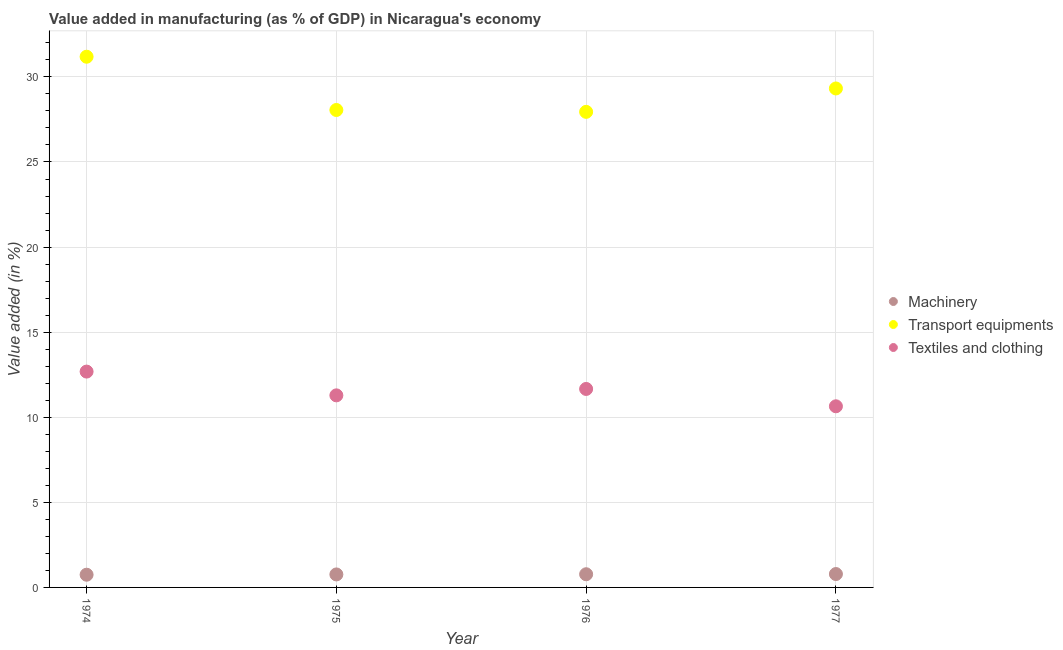Is the number of dotlines equal to the number of legend labels?
Provide a short and direct response. Yes. What is the value added in manufacturing machinery in 1977?
Make the answer very short. 0.79. Across all years, what is the maximum value added in manufacturing transport equipments?
Provide a short and direct response. 31.19. Across all years, what is the minimum value added in manufacturing transport equipments?
Offer a terse response. 27.95. In which year was the value added in manufacturing machinery maximum?
Give a very brief answer. 1977. In which year was the value added in manufacturing transport equipments minimum?
Offer a very short reply. 1976. What is the total value added in manufacturing textile and clothing in the graph?
Keep it short and to the point. 46.28. What is the difference between the value added in manufacturing transport equipments in 1974 and that in 1976?
Offer a terse response. 3.24. What is the difference between the value added in manufacturing textile and clothing in 1975 and the value added in manufacturing transport equipments in 1976?
Keep it short and to the point. -16.66. What is the average value added in manufacturing machinery per year?
Your response must be concise. 0.77. In the year 1977, what is the difference between the value added in manufacturing machinery and value added in manufacturing transport equipments?
Keep it short and to the point. -28.53. In how many years, is the value added in manufacturing machinery greater than 17 %?
Your answer should be compact. 0. What is the ratio of the value added in manufacturing machinery in 1976 to that in 1977?
Your response must be concise. 0.98. Is the difference between the value added in manufacturing transport equipments in 1975 and 1977 greater than the difference between the value added in manufacturing textile and clothing in 1975 and 1977?
Make the answer very short. No. What is the difference between the highest and the second highest value added in manufacturing transport equipments?
Offer a very short reply. 1.87. What is the difference between the highest and the lowest value added in manufacturing machinery?
Make the answer very short. 0.04. In how many years, is the value added in manufacturing textile and clothing greater than the average value added in manufacturing textile and clothing taken over all years?
Offer a terse response. 2. Is the sum of the value added in manufacturing textile and clothing in 1974 and 1975 greater than the maximum value added in manufacturing transport equipments across all years?
Make the answer very short. No. Is it the case that in every year, the sum of the value added in manufacturing machinery and value added in manufacturing transport equipments is greater than the value added in manufacturing textile and clothing?
Make the answer very short. Yes. Is the value added in manufacturing machinery strictly greater than the value added in manufacturing textile and clothing over the years?
Offer a very short reply. No. Is the value added in manufacturing textile and clothing strictly less than the value added in manufacturing transport equipments over the years?
Make the answer very short. Yes. How many years are there in the graph?
Your answer should be compact. 4. Does the graph contain grids?
Your answer should be compact. Yes. Where does the legend appear in the graph?
Keep it short and to the point. Center right. What is the title of the graph?
Provide a succinct answer. Value added in manufacturing (as % of GDP) in Nicaragua's economy. What is the label or title of the X-axis?
Offer a terse response. Year. What is the label or title of the Y-axis?
Provide a short and direct response. Value added (in %). What is the Value added (in %) in Machinery in 1974?
Offer a very short reply. 0.75. What is the Value added (in %) of Transport equipments in 1974?
Make the answer very short. 31.19. What is the Value added (in %) in Textiles and clothing in 1974?
Provide a succinct answer. 12.68. What is the Value added (in %) of Machinery in 1975?
Make the answer very short. 0.76. What is the Value added (in %) of Transport equipments in 1975?
Ensure brevity in your answer.  28.06. What is the Value added (in %) in Textiles and clothing in 1975?
Give a very brief answer. 11.29. What is the Value added (in %) of Machinery in 1976?
Make the answer very short. 0.77. What is the Value added (in %) of Transport equipments in 1976?
Your response must be concise. 27.95. What is the Value added (in %) of Textiles and clothing in 1976?
Provide a short and direct response. 11.66. What is the Value added (in %) of Machinery in 1977?
Make the answer very short. 0.79. What is the Value added (in %) of Transport equipments in 1977?
Ensure brevity in your answer.  29.32. What is the Value added (in %) in Textiles and clothing in 1977?
Make the answer very short. 10.64. Across all years, what is the maximum Value added (in %) of Machinery?
Your response must be concise. 0.79. Across all years, what is the maximum Value added (in %) of Transport equipments?
Provide a succinct answer. 31.19. Across all years, what is the maximum Value added (in %) in Textiles and clothing?
Offer a very short reply. 12.68. Across all years, what is the minimum Value added (in %) in Machinery?
Give a very brief answer. 0.75. Across all years, what is the minimum Value added (in %) in Transport equipments?
Make the answer very short. 27.95. Across all years, what is the minimum Value added (in %) in Textiles and clothing?
Give a very brief answer. 10.64. What is the total Value added (in %) of Machinery in the graph?
Offer a terse response. 3.07. What is the total Value added (in %) of Transport equipments in the graph?
Provide a succinct answer. 116.51. What is the total Value added (in %) of Textiles and clothing in the graph?
Give a very brief answer. 46.28. What is the difference between the Value added (in %) of Machinery in 1974 and that in 1975?
Your answer should be compact. -0.02. What is the difference between the Value added (in %) in Transport equipments in 1974 and that in 1975?
Keep it short and to the point. 3.13. What is the difference between the Value added (in %) of Textiles and clothing in 1974 and that in 1975?
Offer a terse response. 1.4. What is the difference between the Value added (in %) of Machinery in 1974 and that in 1976?
Ensure brevity in your answer.  -0.03. What is the difference between the Value added (in %) in Transport equipments in 1974 and that in 1976?
Offer a terse response. 3.24. What is the difference between the Value added (in %) of Textiles and clothing in 1974 and that in 1976?
Ensure brevity in your answer.  1.02. What is the difference between the Value added (in %) in Machinery in 1974 and that in 1977?
Make the answer very short. -0.04. What is the difference between the Value added (in %) of Transport equipments in 1974 and that in 1977?
Keep it short and to the point. 1.87. What is the difference between the Value added (in %) in Textiles and clothing in 1974 and that in 1977?
Offer a terse response. 2.04. What is the difference between the Value added (in %) of Machinery in 1975 and that in 1976?
Provide a short and direct response. -0.01. What is the difference between the Value added (in %) in Transport equipments in 1975 and that in 1976?
Offer a terse response. 0.11. What is the difference between the Value added (in %) in Textiles and clothing in 1975 and that in 1976?
Ensure brevity in your answer.  -0.38. What is the difference between the Value added (in %) of Machinery in 1975 and that in 1977?
Give a very brief answer. -0.02. What is the difference between the Value added (in %) in Transport equipments in 1975 and that in 1977?
Your response must be concise. -1.26. What is the difference between the Value added (in %) in Textiles and clothing in 1975 and that in 1977?
Make the answer very short. 0.64. What is the difference between the Value added (in %) in Machinery in 1976 and that in 1977?
Your answer should be compact. -0.01. What is the difference between the Value added (in %) in Transport equipments in 1976 and that in 1977?
Make the answer very short. -1.37. What is the difference between the Value added (in %) in Textiles and clothing in 1976 and that in 1977?
Make the answer very short. 1.02. What is the difference between the Value added (in %) in Machinery in 1974 and the Value added (in %) in Transport equipments in 1975?
Provide a succinct answer. -27.31. What is the difference between the Value added (in %) of Machinery in 1974 and the Value added (in %) of Textiles and clothing in 1975?
Your response must be concise. -10.54. What is the difference between the Value added (in %) in Transport equipments in 1974 and the Value added (in %) in Textiles and clothing in 1975?
Offer a terse response. 19.9. What is the difference between the Value added (in %) in Machinery in 1974 and the Value added (in %) in Transport equipments in 1976?
Make the answer very short. -27.2. What is the difference between the Value added (in %) of Machinery in 1974 and the Value added (in %) of Textiles and clothing in 1976?
Your answer should be very brief. -10.92. What is the difference between the Value added (in %) in Transport equipments in 1974 and the Value added (in %) in Textiles and clothing in 1976?
Provide a succinct answer. 19.52. What is the difference between the Value added (in %) in Machinery in 1974 and the Value added (in %) in Transport equipments in 1977?
Keep it short and to the point. -28.57. What is the difference between the Value added (in %) in Machinery in 1974 and the Value added (in %) in Textiles and clothing in 1977?
Provide a succinct answer. -9.9. What is the difference between the Value added (in %) in Transport equipments in 1974 and the Value added (in %) in Textiles and clothing in 1977?
Provide a succinct answer. 20.54. What is the difference between the Value added (in %) of Machinery in 1975 and the Value added (in %) of Transport equipments in 1976?
Your answer should be compact. -27.18. What is the difference between the Value added (in %) of Machinery in 1975 and the Value added (in %) of Textiles and clothing in 1976?
Keep it short and to the point. -10.9. What is the difference between the Value added (in %) in Transport equipments in 1975 and the Value added (in %) in Textiles and clothing in 1976?
Offer a very short reply. 16.39. What is the difference between the Value added (in %) of Machinery in 1975 and the Value added (in %) of Transport equipments in 1977?
Offer a very short reply. -28.56. What is the difference between the Value added (in %) of Machinery in 1975 and the Value added (in %) of Textiles and clothing in 1977?
Your answer should be very brief. -9.88. What is the difference between the Value added (in %) in Transport equipments in 1975 and the Value added (in %) in Textiles and clothing in 1977?
Provide a succinct answer. 17.41. What is the difference between the Value added (in %) in Machinery in 1976 and the Value added (in %) in Transport equipments in 1977?
Your answer should be very brief. -28.55. What is the difference between the Value added (in %) of Machinery in 1976 and the Value added (in %) of Textiles and clothing in 1977?
Ensure brevity in your answer.  -9.87. What is the difference between the Value added (in %) of Transport equipments in 1976 and the Value added (in %) of Textiles and clothing in 1977?
Make the answer very short. 17.3. What is the average Value added (in %) of Machinery per year?
Offer a terse response. 0.77. What is the average Value added (in %) of Transport equipments per year?
Offer a terse response. 29.13. What is the average Value added (in %) in Textiles and clothing per year?
Offer a very short reply. 11.57. In the year 1974, what is the difference between the Value added (in %) of Machinery and Value added (in %) of Transport equipments?
Keep it short and to the point. -30.44. In the year 1974, what is the difference between the Value added (in %) of Machinery and Value added (in %) of Textiles and clothing?
Give a very brief answer. -11.94. In the year 1974, what is the difference between the Value added (in %) in Transport equipments and Value added (in %) in Textiles and clothing?
Your response must be concise. 18.5. In the year 1975, what is the difference between the Value added (in %) of Machinery and Value added (in %) of Transport equipments?
Ensure brevity in your answer.  -27.29. In the year 1975, what is the difference between the Value added (in %) in Machinery and Value added (in %) in Textiles and clothing?
Your answer should be compact. -10.52. In the year 1975, what is the difference between the Value added (in %) in Transport equipments and Value added (in %) in Textiles and clothing?
Give a very brief answer. 16.77. In the year 1976, what is the difference between the Value added (in %) in Machinery and Value added (in %) in Transport equipments?
Your answer should be compact. -27.17. In the year 1976, what is the difference between the Value added (in %) of Machinery and Value added (in %) of Textiles and clothing?
Keep it short and to the point. -10.89. In the year 1976, what is the difference between the Value added (in %) in Transport equipments and Value added (in %) in Textiles and clothing?
Offer a very short reply. 16.28. In the year 1977, what is the difference between the Value added (in %) of Machinery and Value added (in %) of Transport equipments?
Make the answer very short. -28.53. In the year 1977, what is the difference between the Value added (in %) in Machinery and Value added (in %) in Textiles and clothing?
Provide a succinct answer. -9.86. In the year 1977, what is the difference between the Value added (in %) in Transport equipments and Value added (in %) in Textiles and clothing?
Give a very brief answer. 18.68. What is the ratio of the Value added (in %) in Machinery in 1974 to that in 1975?
Provide a succinct answer. 0.98. What is the ratio of the Value added (in %) in Transport equipments in 1974 to that in 1975?
Your answer should be very brief. 1.11. What is the ratio of the Value added (in %) of Textiles and clothing in 1974 to that in 1975?
Offer a terse response. 1.12. What is the ratio of the Value added (in %) in Machinery in 1974 to that in 1976?
Your response must be concise. 0.96. What is the ratio of the Value added (in %) of Transport equipments in 1974 to that in 1976?
Offer a very short reply. 1.12. What is the ratio of the Value added (in %) of Textiles and clothing in 1974 to that in 1976?
Your response must be concise. 1.09. What is the ratio of the Value added (in %) in Machinery in 1974 to that in 1977?
Make the answer very short. 0.95. What is the ratio of the Value added (in %) in Transport equipments in 1974 to that in 1977?
Keep it short and to the point. 1.06. What is the ratio of the Value added (in %) in Textiles and clothing in 1974 to that in 1977?
Your response must be concise. 1.19. What is the ratio of the Value added (in %) of Machinery in 1975 to that in 1976?
Give a very brief answer. 0.99. What is the ratio of the Value added (in %) in Machinery in 1975 to that in 1977?
Offer a very short reply. 0.97. What is the ratio of the Value added (in %) of Transport equipments in 1975 to that in 1977?
Provide a short and direct response. 0.96. What is the ratio of the Value added (in %) in Textiles and clothing in 1975 to that in 1977?
Keep it short and to the point. 1.06. What is the ratio of the Value added (in %) in Machinery in 1976 to that in 1977?
Offer a very short reply. 0.98. What is the ratio of the Value added (in %) of Transport equipments in 1976 to that in 1977?
Your answer should be very brief. 0.95. What is the ratio of the Value added (in %) of Textiles and clothing in 1976 to that in 1977?
Provide a short and direct response. 1.1. What is the difference between the highest and the second highest Value added (in %) in Machinery?
Give a very brief answer. 0.01. What is the difference between the highest and the second highest Value added (in %) in Transport equipments?
Provide a succinct answer. 1.87. What is the difference between the highest and the second highest Value added (in %) of Textiles and clothing?
Your answer should be very brief. 1.02. What is the difference between the highest and the lowest Value added (in %) in Machinery?
Your answer should be very brief. 0.04. What is the difference between the highest and the lowest Value added (in %) of Transport equipments?
Provide a succinct answer. 3.24. What is the difference between the highest and the lowest Value added (in %) of Textiles and clothing?
Keep it short and to the point. 2.04. 